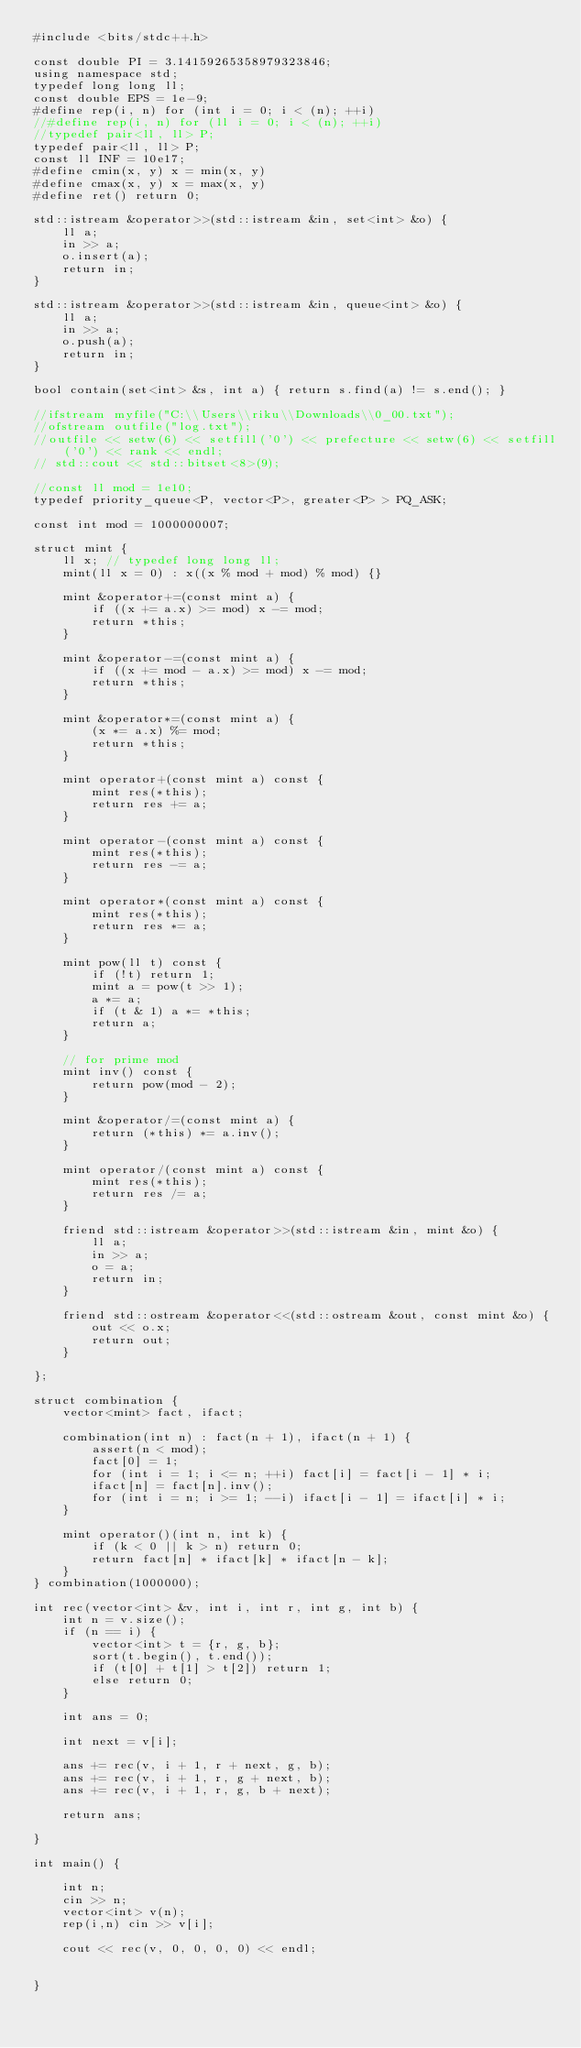Convert code to text. <code><loc_0><loc_0><loc_500><loc_500><_C++_>#include <bits/stdc++.h>

const double PI = 3.14159265358979323846;
using namespace std;
typedef long long ll;
const double EPS = 1e-9;
#define rep(i, n) for (int i = 0; i < (n); ++i)
//#define rep(i, n) for (ll i = 0; i < (n); ++i)
//typedef pair<ll, ll> P;
typedef pair<ll, ll> P;
const ll INF = 10e17;
#define cmin(x, y) x = min(x, y)
#define cmax(x, y) x = max(x, y)
#define ret() return 0;

std::istream &operator>>(std::istream &in, set<int> &o) {
    ll a;
    in >> a;
    o.insert(a);
    return in;
}

std::istream &operator>>(std::istream &in, queue<int> &o) {
    ll a;
    in >> a;
    o.push(a);
    return in;
}

bool contain(set<int> &s, int a) { return s.find(a) != s.end(); }

//ifstream myfile("C:\\Users\\riku\\Downloads\\0_00.txt");
//ofstream outfile("log.txt");
//outfile << setw(6) << setfill('0') << prefecture << setw(6) << setfill('0') << rank << endl;
// std::cout << std::bitset<8>(9);

//const ll mod = 1e10;
typedef priority_queue<P, vector<P>, greater<P> > PQ_ASK;

const int mod = 1000000007;

struct mint {
    ll x; // typedef long long ll;
    mint(ll x = 0) : x((x % mod + mod) % mod) {}

    mint &operator+=(const mint a) {
        if ((x += a.x) >= mod) x -= mod;
        return *this;
    }

    mint &operator-=(const mint a) {
        if ((x += mod - a.x) >= mod) x -= mod;
        return *this;
    }

    mint &operator*=(const mint a) {
        (x *= a.x) %= mod;
        return *this;
    }

    mint operator+(const mint a) const {
        mint res(*this);
        return res += a;
    }

    mint operator-(const mint a) const {
        mint res(*this);
        return res -= a;
    }

    mint operator*(const mint a) const {
        mint res(*this);
        return res *= a;
    }

    mint pow(ll t) const {
        if (!t) return 1;
        mint a = pow(t >> 1);
        a *= a;
        if (t & 1) a *= *this;
        return a;
    }

    // for prime mod
    mint inv() const {
        return pow(mod - 2);
    }

    mint &operator/=(const mint a) {
        return (*this) *= a.inv();
    }

    mint operator/(const mint a) const {
        mint res(*this);
        return res /= a;
    }

    friend std::istream &operator>>(std::istream &in, mint &o) {
        ll a;
        in >> a;
        o = a;
        return in;
    }

    friend std::ostream &operator<<(std::ostream &out, const mint &o) {
        out << o.x;
        return out;
    }

};

struct combination {
    vector<mint> fact, ifact;

    combination(int n) : fact(n + 1), ifact(n + 1) {
        assert(n < mod);
        fact[0] = 1;
        for (int i = 1; i <= n; ++i) fact[i] = fact[i - 1] * i;
        ifact[n] = fact[n].inv();
        for (int i = n; i >= 1; --i) ifact[i - 1] = ifact[i] * i;
    }

    mint operator()(int n, int k) {
        if (k < 0 || k > n) return 0;
        return fact[n] * ifact[k] * ifact[n - k];
    }
} combination(1000000);

int rec(vector<int> &v, int i, int r, int g, int b) {
    int n = v.size();
    if (n == i) {
        vector<int> t = {r, g, b};
        sort(t.begin(), t.end());
        if (t[0] + t[1] > t[2]) return 1;
        else return 0;
    }

    int ans = 0;

    int next = v[i];

    ans += rec(v, i + 1, r + next, g, b);
    ans += rec(v, i + 1, r, g + next, b);
    ans += rec(v, i + 1, r, g, b + next);

    return ans;

}

int main() {

    int n;
    cin >> n;
    vector<int> v(n);
    rep(i,n) cin >> v[i];

    cout << rec(v, 0, 0, 0, 0) << endl;


}</code> 